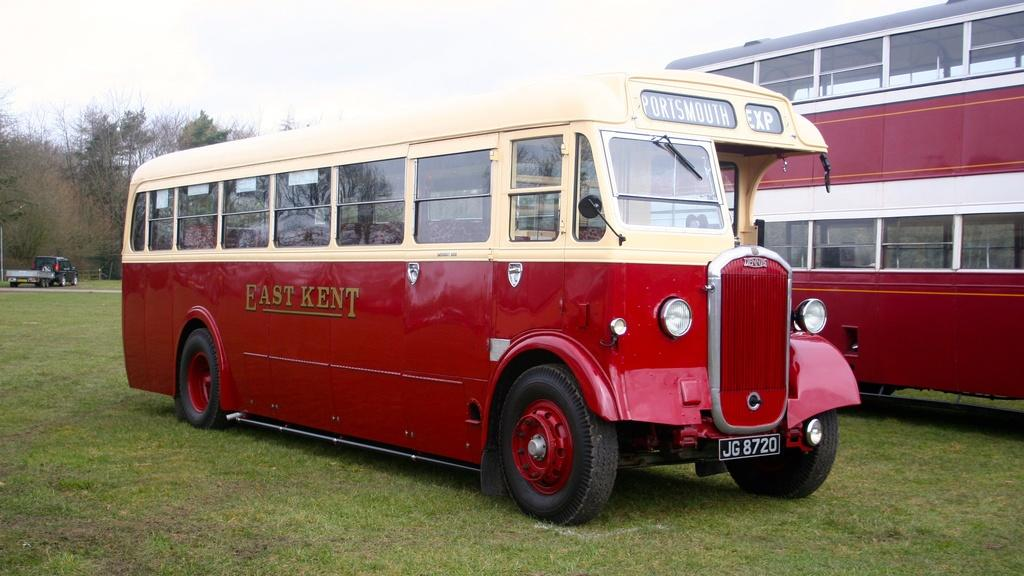What type of vehicle is in the image? There is a red color Double Decker bus in the image. Can you describe any other vehicles in the image? Yes, there is a truck in the image. Where are the bus and truck located in the image? The bus and truck are on the grass. What can be seen in the background of the image? There are trees and the sky visible in the background of the image. What type of smile can be seen on the bus in the image? There is no smile present on the bus in the image, as it is an inanimate object. 